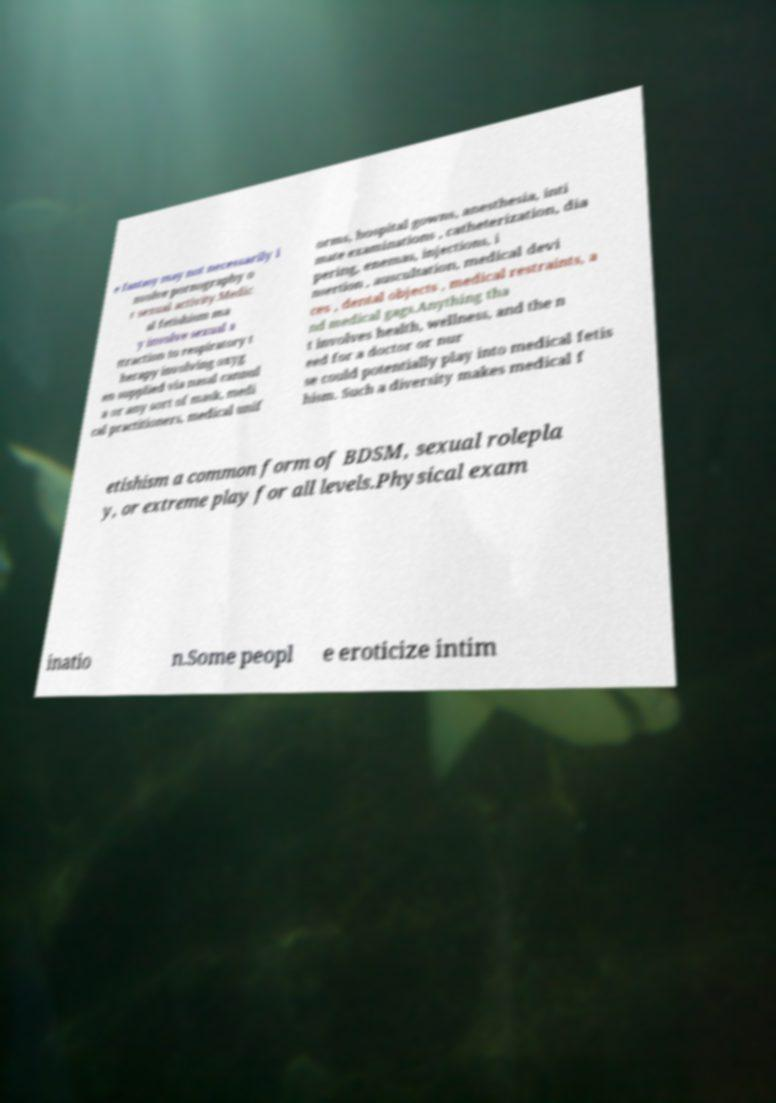Could you assist in decoding the text presented in this image and type it out clearly? e fantasy may not necessarily i nvolve pornography o r sexual activity.Medic al fetishism ma y involve sexual a ttraction to respiratory t herapy involving oxyg en supplied via nasal cannul a or any sort of mask, medi cal practitioners, medical unif orms, hospital gowns, anesthesia, inti mate examinations , catheterization, dia pering, enemas, injections, i nsertion , auscultation, medical devi ces , dental objects , medical restraints, a nd medical gags.Anything tha t involves health, wellness, and the n eed for a doctor or nur se could potentially play into medical fetis hism. Such a diversity makes medical f etishism a common form of BDSM, sexual rolepla y, or extreme play for all levels.Physical exam inatio n.Some peopl e eroticize intim 